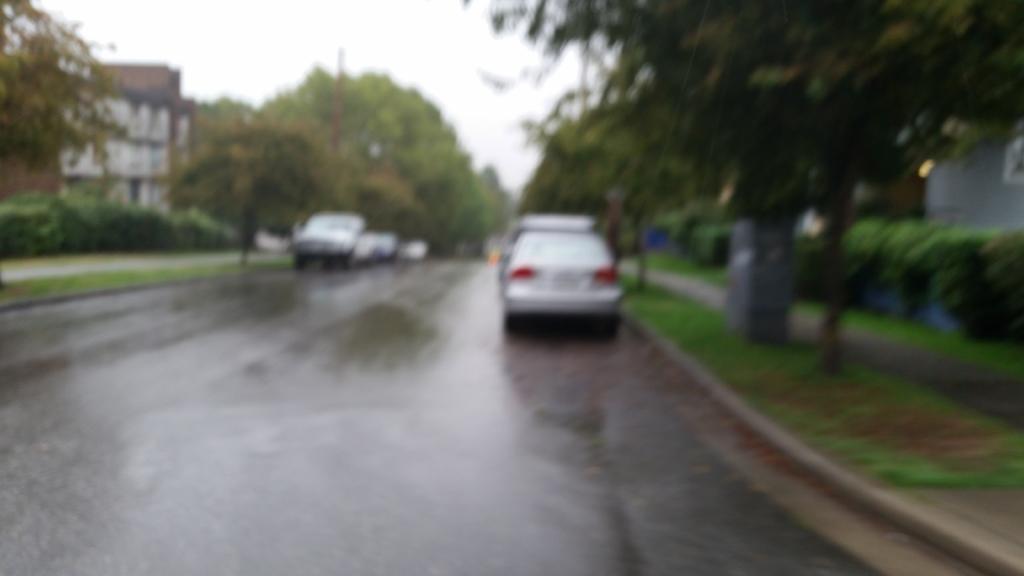In one or two sentences, can you explain what this image depicts? In this image I can see vehicles on a road. There are trees and buildings on the either sides of the road. There is sky at the top and this is a blurred image. 